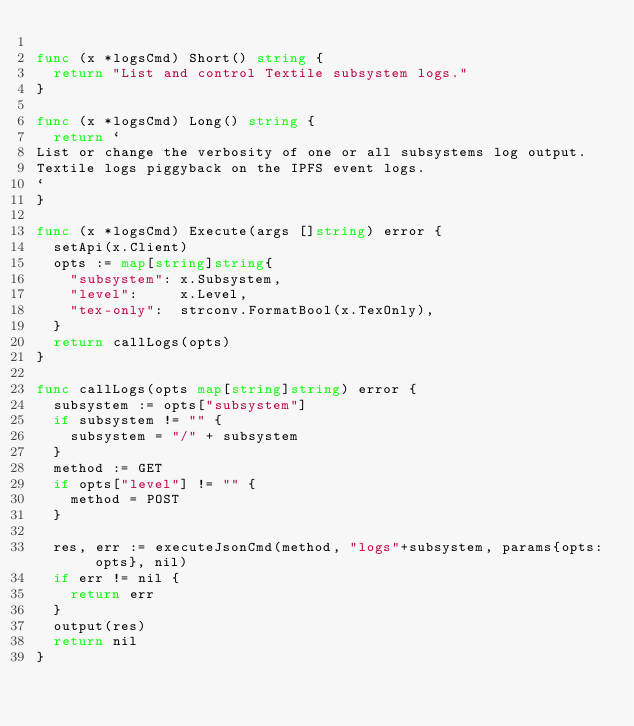<code> <loc_0><loc_0><loc_500><loc_500><_Go_>
func (x *logsCmd) Short() string {
	return "List and control Textile subsystem logs."
}

func (x *logsCmd) Long() string {
	return `
List or change the verbosity of one or all subsystems log output.
Textile logs piggyback on the IPFS event logs.
`
}

func (x *logsCmd) Execute(args []string) error {
	setApi(x.Client)
	opts := map[string]string{
		"subsystem": x.Subsystem,
		"level":     x.Level,
		"tex-only":  strconv.FormatBool(x.TexOnly),
	}
	return callLogs(opts)
}

func callLogs(opts map[string]string) error {
	subsystem := opts["subsystem"]
	if subsystem != "" {
		subsystem = "/" + subsystem
	}
	method := GET
	if opts["level"] != "" {
		method = POST
	}

	res, err := executeJsonCmd(method, "logs"+subsystem, params{opts: opts}, nil)
	if err != nil {
		return err
	}
	output(res)
	return nil
}
</code> 